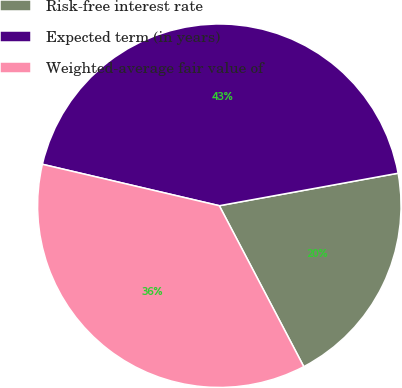Convert chart to OTSL. <chart><loc_0><loc_0><loc_500><loc_500><pie_chart><fcel>Risk-free interest rate<fcel>Expected term (in years)<fcel>Weighted-average fair value of<nl><fcel>20.17%<fcel>43.48%<fcel>36.36%<nl></chart> 